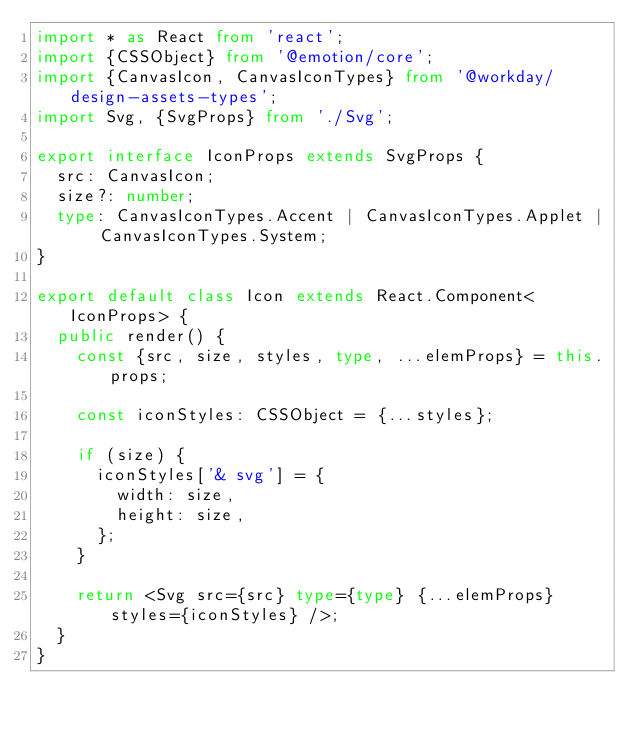<code> <loc_0><loc_0><loc_500><loc_500><_TypeScript_>import * as React from 'react';
import {CSSObject} from '@emotion/core';
import {CanvasIcon, CanvasIconTypes} from '@workday/design-assets-types';
import Svg, {SvgProps} from './Svg';

export interface IconProps extends SvgProps {
  src: CanvasIcon;
  size?: number;
  type: CanvasIconTypes.Accent | CanvasIconTypes.Applet | CanvasIconTypes.System;
}

export default class Icon extends React.Component<IconProps> {
  public render() {
    const {src, size, styles, type, ...elemProps} = this.props;

    const iconStyles: CSSObject = {...styles};

    if (size) {
      iconStyles['& svg'] = {
        width: size,
        height: size,
      };
    }

    return <Svg src={src} type={type} {...elemProps} styles={iconStyles} />;
  }
}
</code> 